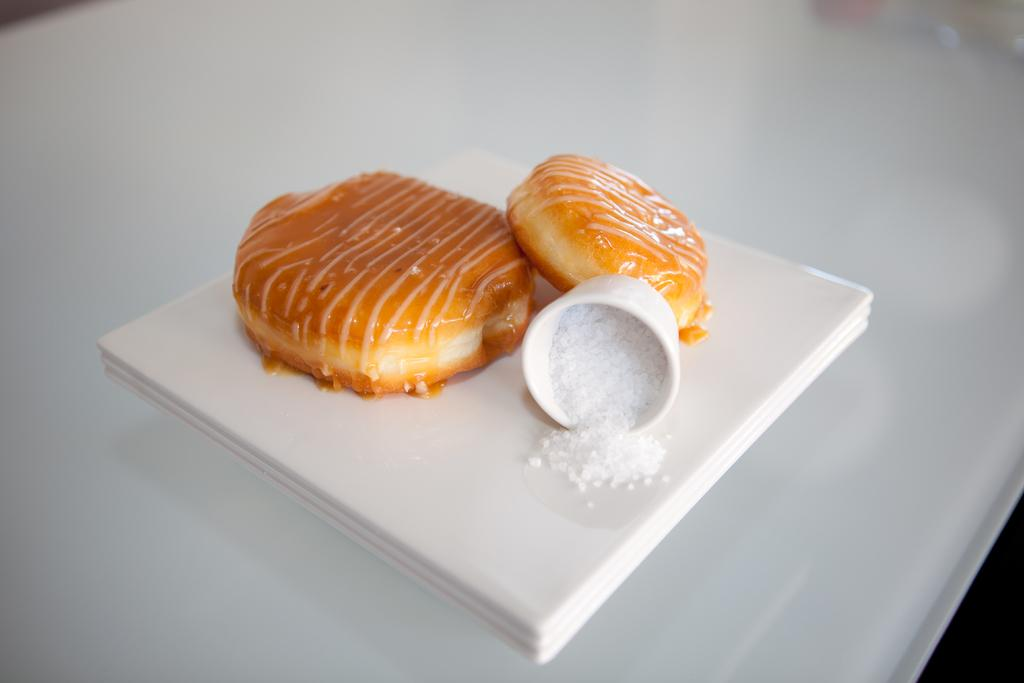What is placed on the plate in the image? There is food placed in a plate. Where is the plate located? The plate is on a table. What type of soap is being used to clean the apple in the image? There is no apple or soap present in the image; it only features food placed on a plate. 